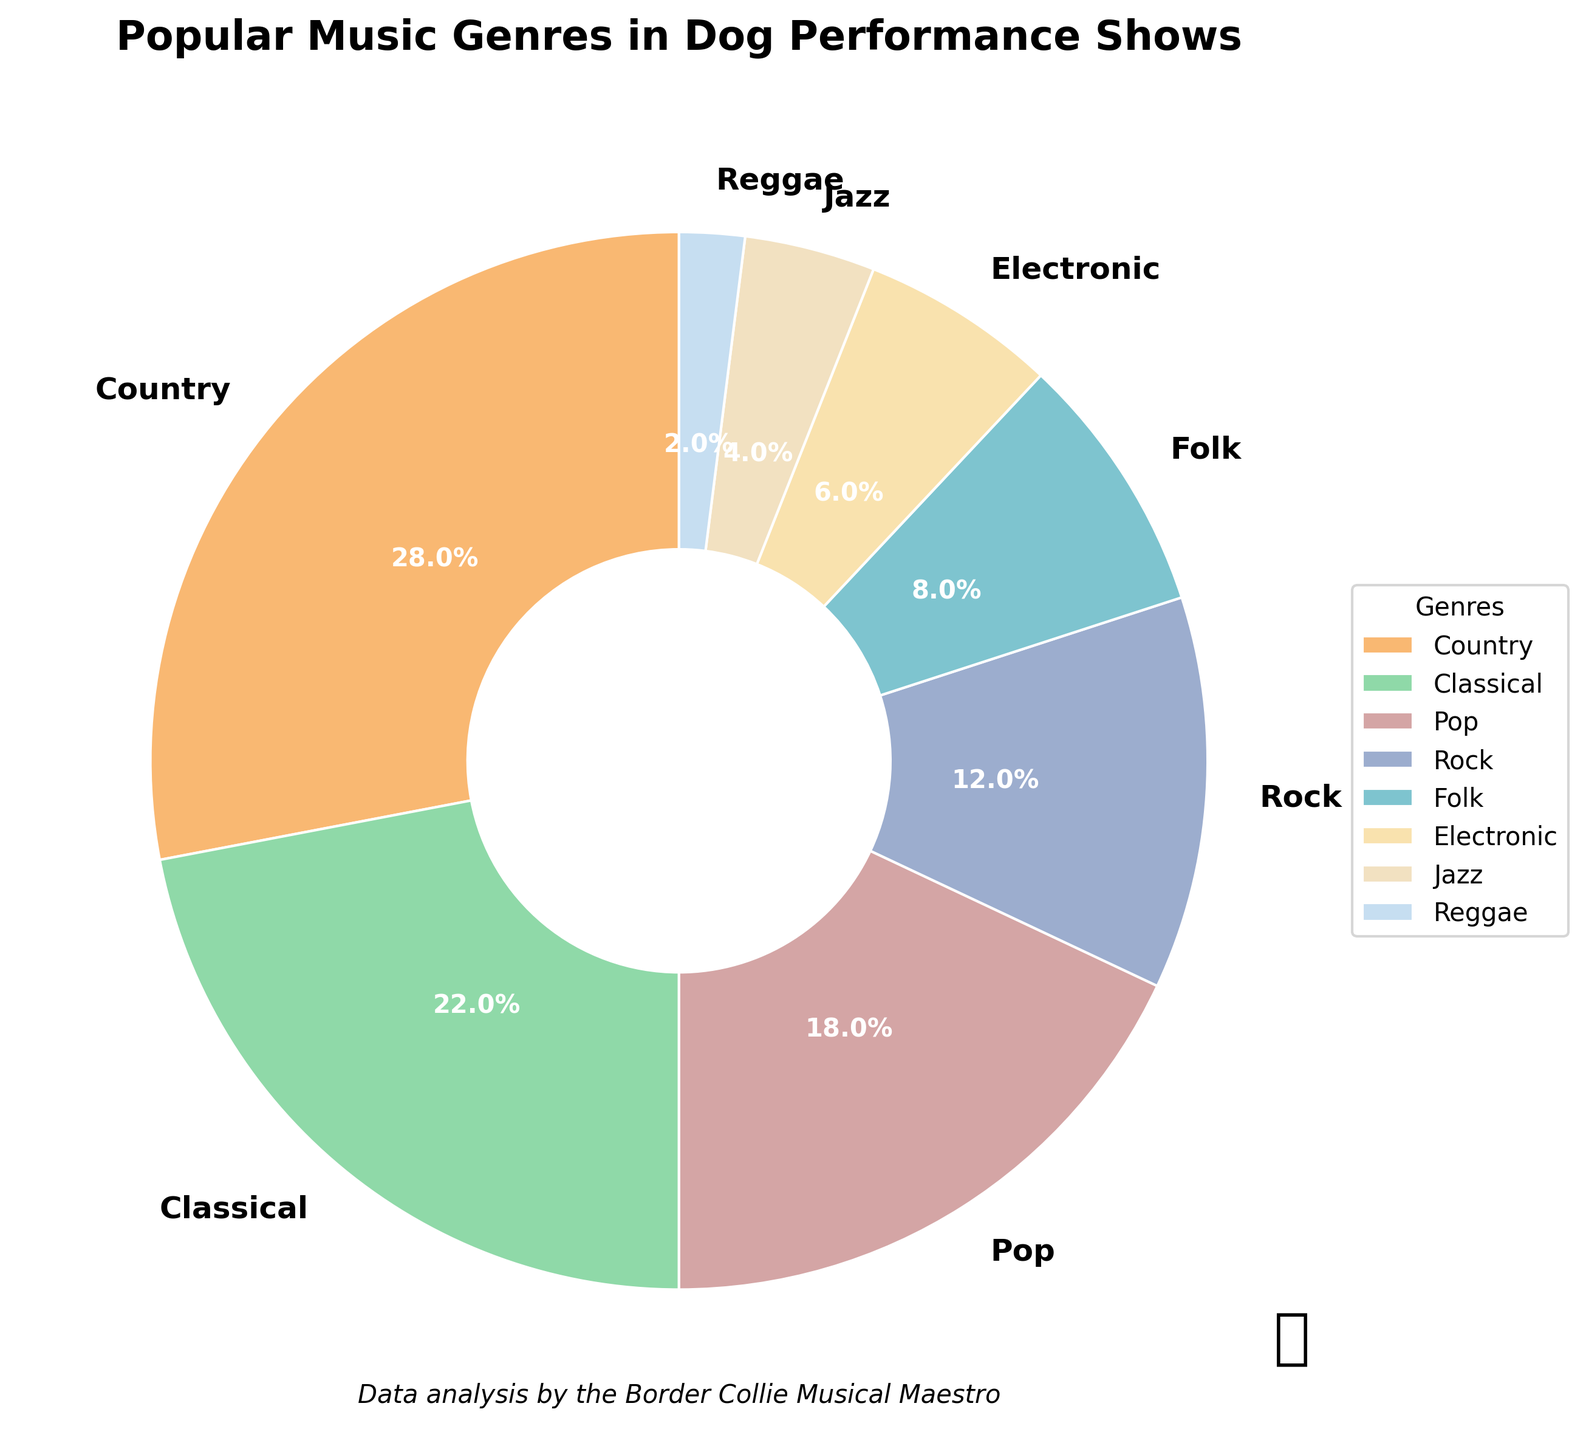What percentage of the music genres used in dog performance shows is Country? The Country section of the pie chart shows 28%.
Answer: 28% How does the proportion of Classical music compare to Pop music in dog shows? Classical music has 22%, while Pop has 18%, indicating that Classical music is more prevalent.
Answer: Classical is more prevalent Which genre has the lowest percentage in dog performance shows and what is it? The pie chart shows Reggae with the lowest percentage at 2%.
Answer: Reggae, 2% What is the combined percentage of Rock and Folk music in dog performance shows? Adding the percentages for Rock (12%) and Folk (8%), we get 12 + 8 = 20%.
Answer: 20% Which genre occupies more space in the pie chart: Electronic or Jazz? Electronic music has 6% and Jazz has 4%, so Electronic occupies more space.
Answer: Electronic What is the percentage difference between the most popular and least popular music genres in dog performance shows? The most popular genre is Country at 28%, and the least popular is Reggae at 2%. The difference is 28 - 2 = 26%.
Answer: 26% How much more popular is Country music compared to Rock music in dog performances? Country music is at 28%, while Rock is at 12%. The difference is 28 - 12 = 16%.
Answer: 16% What two genres together make up exactly 30% of the music used in dog shows? The pie chart shows that Folk and Electronic together sum up to 8% + 6% = 14%. Jazz does not fit into pairs to make 30%. However, no two genres fit exactly 30%.
Answer: None match exactly How does the total percentage of Folk and Electronic compare with the total percentage of Pop and Rock? Folk (8%) and Electronic (6%) together are 8 + 6 = 14%. Pop (18%) and Rock (12%) together are 18 + 12 = 30%. Comparing the sums, 30% is higher than 14%.
Answer: Pop and Rock have higher combined percentage Identify the three least popular genres and their combined percentage. The three least popular genres are Jazz (4%), Reggae (2%), and Electronic (6%). Adding these gives 4 + 2 + 6 = 12%.
Answer: Jazz, Reggae, Electronic; 12% 